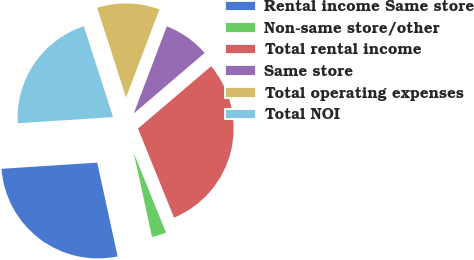<chart> <loc_0><loc_0><loc_500><loc_500><pie_chart><fcel>Rental income Same store<fcel>Non-same store/other<fcel>Total rental income<fcel>Same store<fcel>Total operating expenses<fcel>Total NOI<nl><fcel>27.38%<fcel>2.71%<fcel>30.12%<fcel>7.99%<fcel>10.73%<fcel>21.07%<nl></chart> 